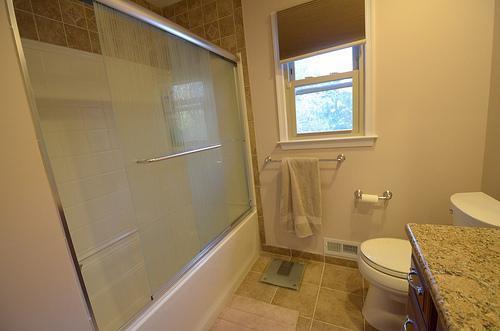How many types of tile are there?
Give a very brief answer. 3. 